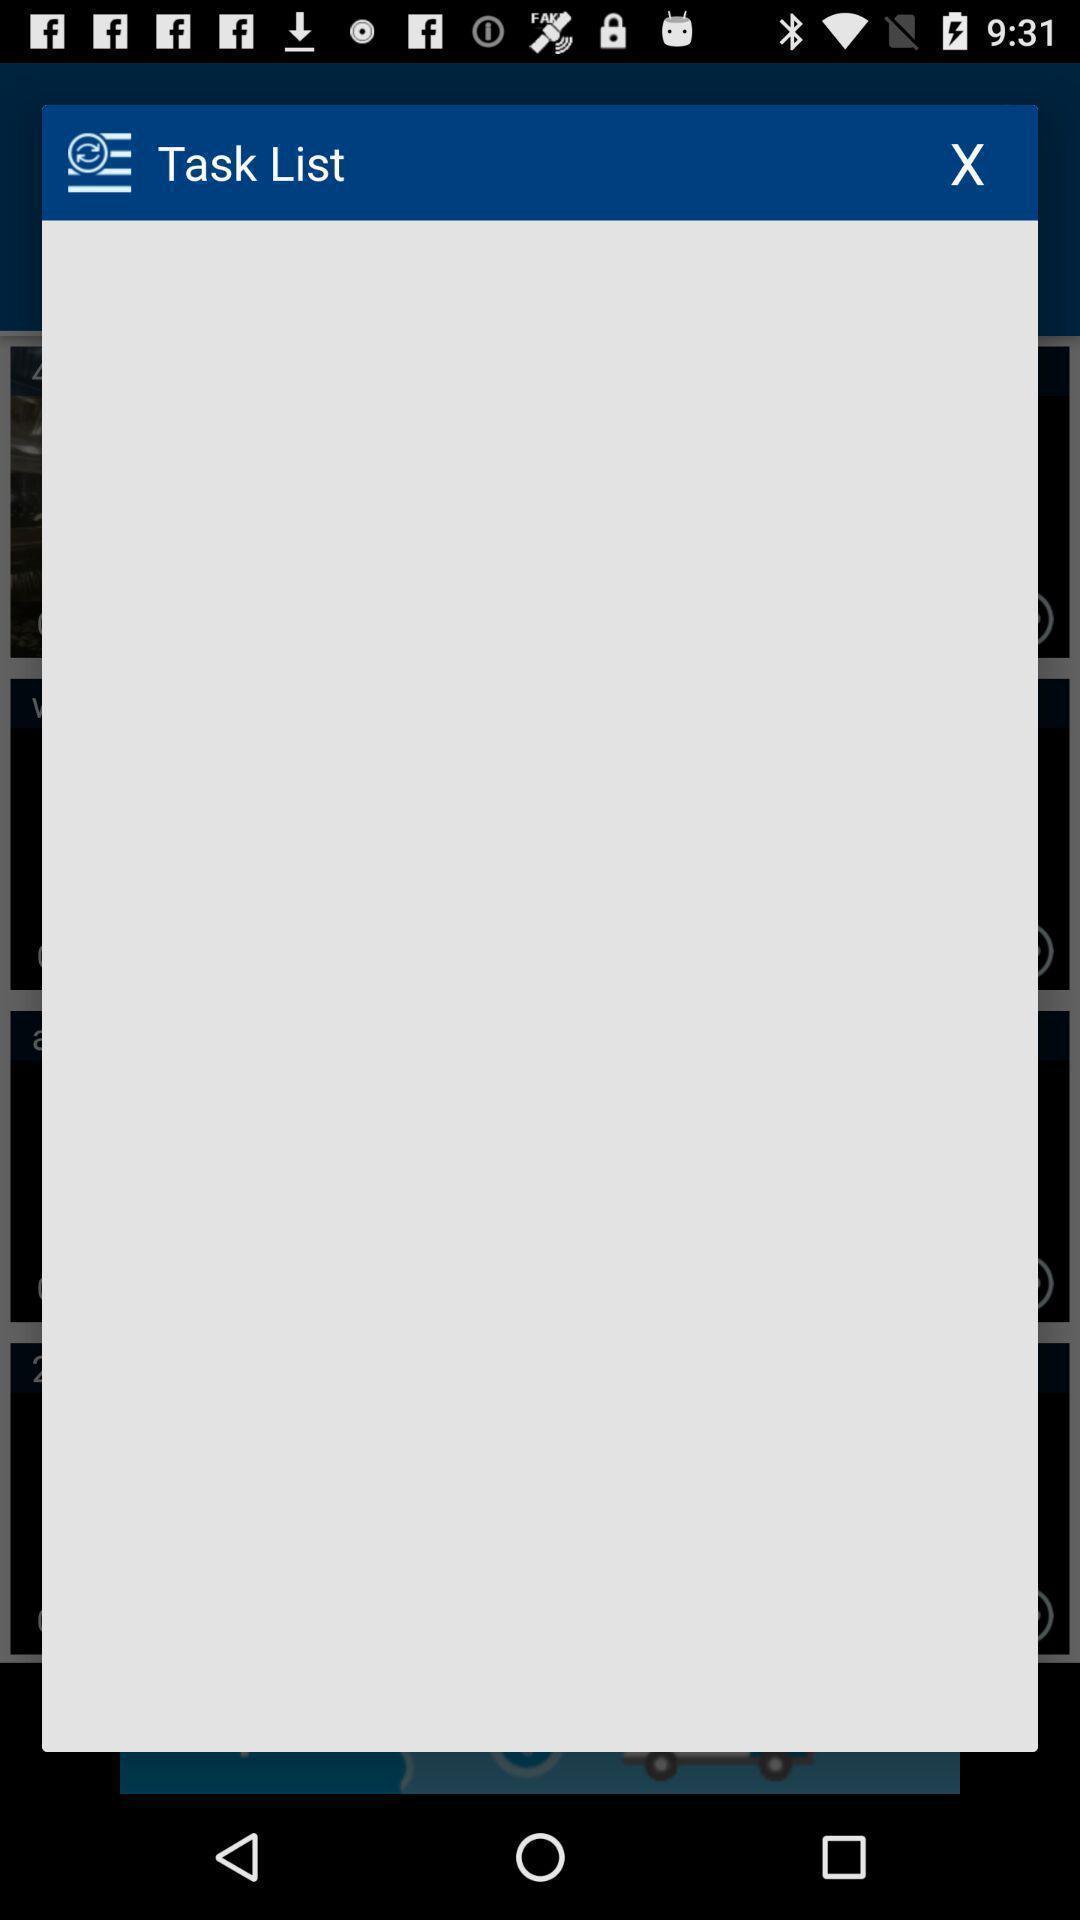Please provide a description for this image. Pop-up shows about task list. 